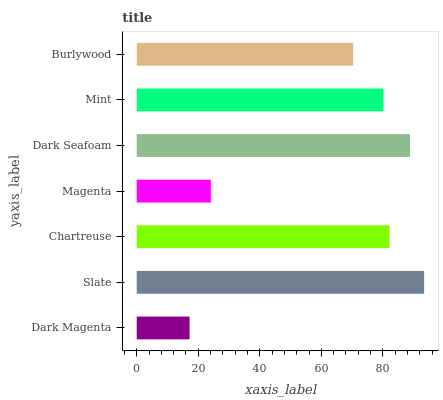Is Dark Magenta the minimum?
Answer yes or no. Yes. Is Slate the maximum?
Answer yes or no. Yes. Is Chartreuse the minimum?
Answer yes or no. No. Is Chartreuse the maximum?
Answer yes or no. No. Is Slate greater than Chartreuse?
Answer yes or no. Yes. Is Chartreuse less than Slate?
Answer yes or no. Yes. Is Chartreuse greater than Slate?
Answer yes or no. No. Is Slate less than Chartreuse?
Answer yes or no. No. Is Mint the high median?
Answer yes or no. Yes. Is Mint the low median?
Answer yes or no. Yes. Is Slate the high median?
Answer yes or no. No. Is Magenta the low median?
Answer yes or no. No. 